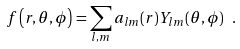Convert formula to latex. <formula><loc_0><loc_0><loc_500><loc_500>f \left ( r , \theta , \phi \right ) = \sum _ { l , m } a _ { l m } ( r ) Y _ { l m } ( \theta , \phi ) \ .</formula> 